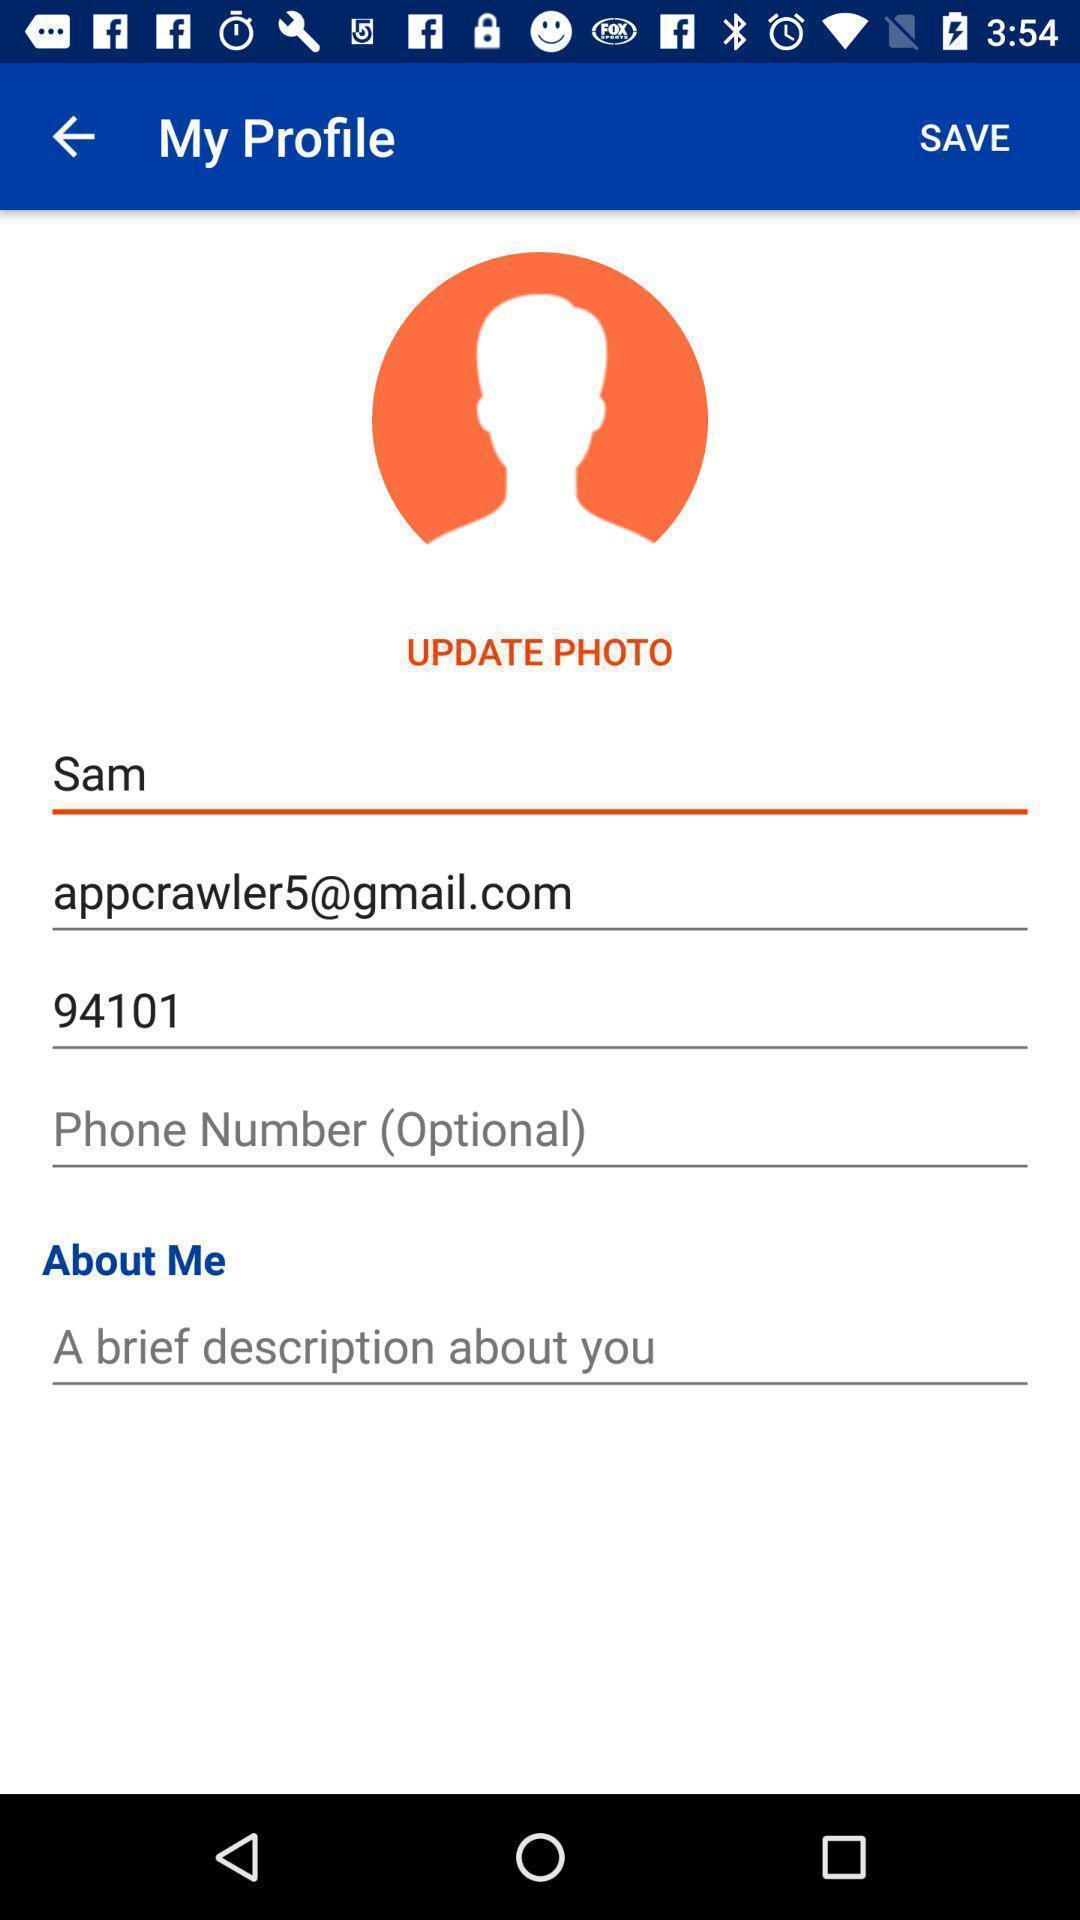Describe the key features of this screenshot. Screen shows to update a photo. 